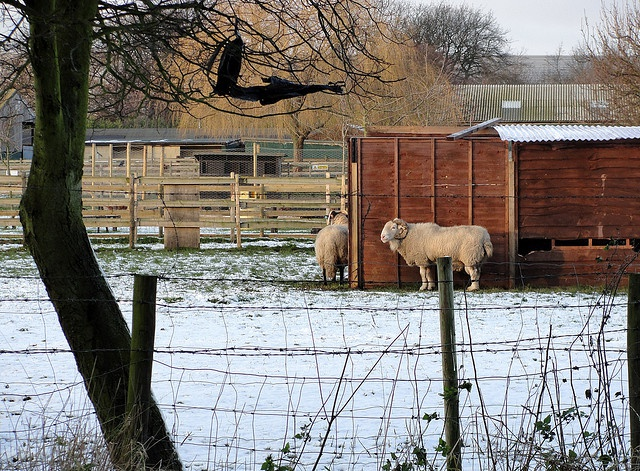Describe the objects in this image and their specific colors. I can see sheep in black, tan, and gray tones and sheep in black, tan, and gray tones in this image. 